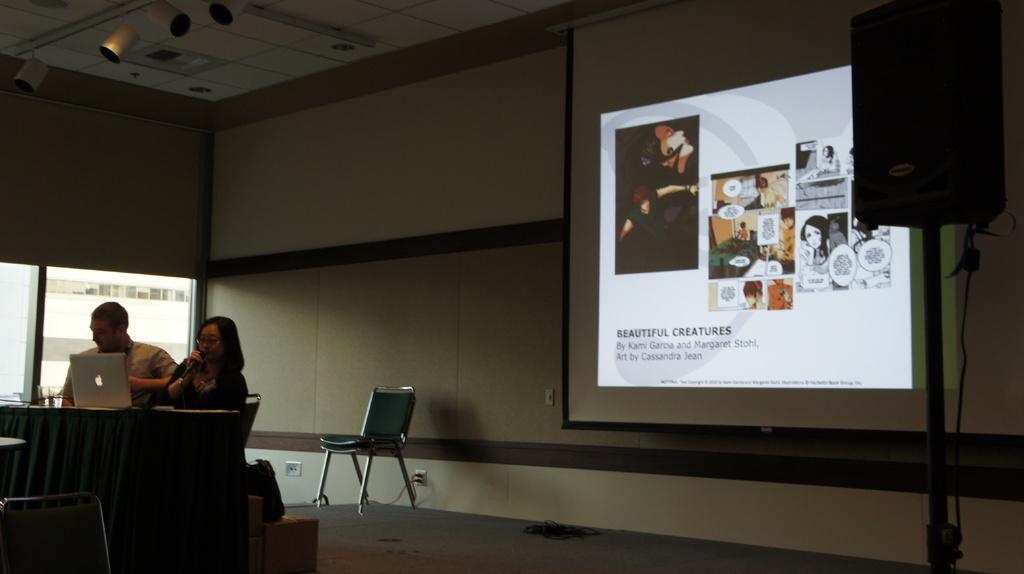In one or two sentences, can you explain what this image depicts? there is a man and woman sitting on the table desk operating a laptop behind them there is a sound box and a screen displayed on the wall. 